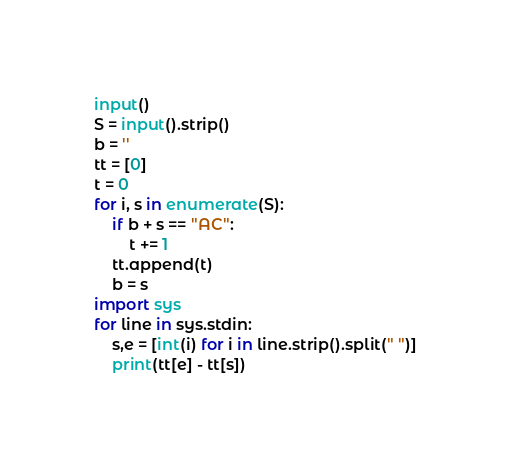Convert code to text. <code><loc_0><loc_0><loc_500><loc_500><_Python_>input()
S = input().strip()
b = ''
tt = [0]
t = 0
for i, s in enumerate(S):
    if b + s == "AC":
        t += 1
    tt.append(t)
    b = s
import sys
for line in sys.stdin:
    s,e = [int(i) for i in line.strip().split(" ")]
    print(tt[e] - tt[s])
</code> 